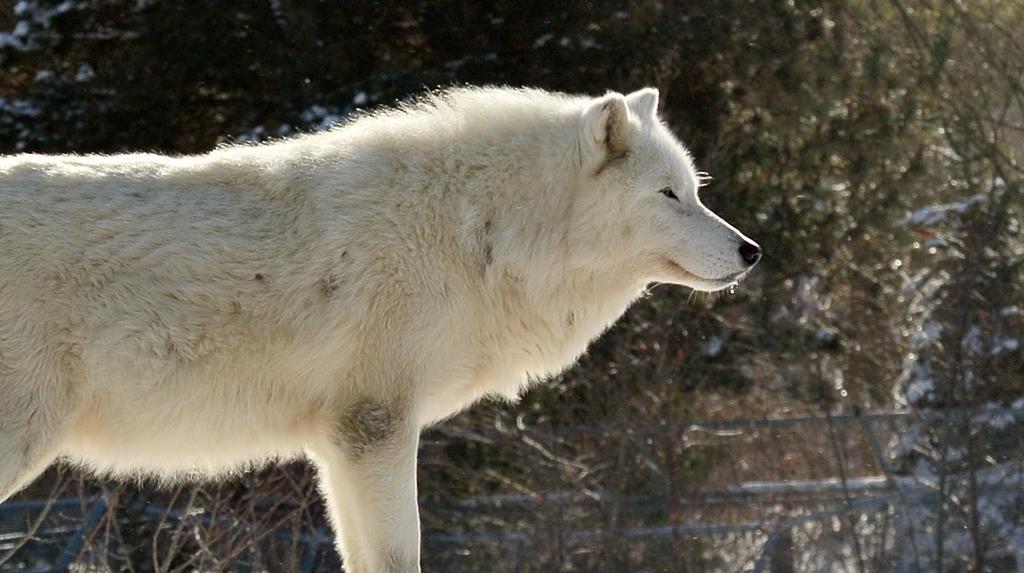How would you summarize this image in a sentence or two? In this picture I can see a white wolf, and in the background there are trees. 